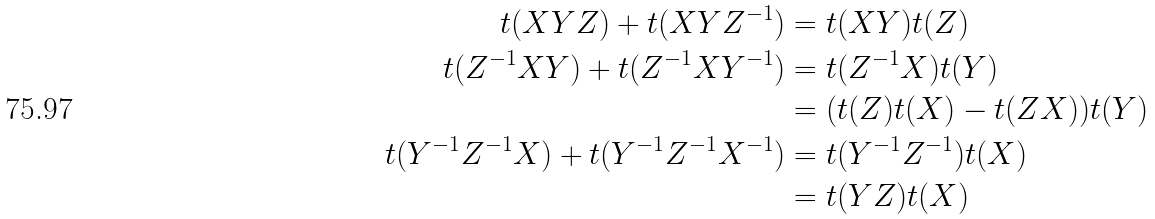<formula> <loc_0><loc_0><loc_500><loc_500>t ( X Y Z ) + t ( X Y Z ^ { - 1 } ) & = t ( X Y ) t ( Z ) \\ t ( Z ^ { - 1 } X Y ) + t ( Z ^ { - 1 } X Y ^ { - 1 } ) & = t ( Z ^ { - 1 } X ) t ( Y ) \\ & = ( t ( Z ) t ( X ) - t ( Z X ) ) t ( Y ) \\ t ( Y ^ { - 1 } Z ^ { - 1 } X ) + t ( Y ^ { - 1 } Z ^ { - 1 } X ^ { - 1 } ) & = t ( Y ^ { - 1 } Z ^ { - 1 } ) t ( X ) \\ & = t ( Y Z ) t ( X )</formula> 